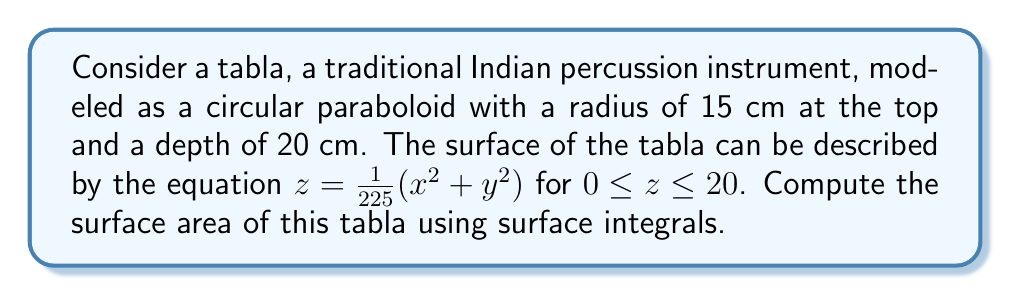Give your solution to this math problem. To compute the surface area using surface integrals, we'll follow these steps:

1) The surface area of a function $z = f(x,y)$ over a region $R$ is given by:

   $$A = \iint_R \sqrt{1 + \left(\frac{\partial z}{\partial x}\right)^2 + \left(\frac{\partial z}{\partial y}\right)^2} dA$$

2) For our paraboloid, $z = \frac{1}{225}(x^2 + y^2)$. Let's calculate the partial derivatives:

   $\frac{\partial z}{\partial x} = \frac{2x}{225}$
   $\frac{\partial z}{\partial y} = \frac{2y}{225}$

3) Substituting these into our surface area formula:

   $$A = \iint_R \sqrt{1 + \left(\frac{2x}{225}\right)^2 + \left(\frac{2y}{225}\right)^2} dA$$

4) The region $R$ is a circle with radius 15. It's easier to use polar coordinates here. The transformation is:

   $x = r\cos\theta$
   $y = r\sin\theta$
   $dA = r dr d\theta$

5) Our integral becomes:

   $$A = \int_0^{2\pi} \int_0^{15} \sqrt{1 + \left(\frac{2r}{225}\right)^2} r dr d\theta$$

6) Simplify the integrand:

   $$A = \int_0^{2\pi} \int_0^{15} \sqrt{1 + \frac{4r^2}{50625}} r dr d\theta$$

7) Evaluate the inner integral:

   $$A = \int_0^{2\pi} \left[\frac{50625}{8}\left(\sqrt{1 + \frac{4r^2}{50625}} - 1\right)\right]_0^{15} d\theta$$

8) Substitute the limits:

   $$A = \int_0^{2\pi} \frac{50625}{8}\left(\sqrt{1 + \frac{900}{50625}} - 1\right) d\theta$$

9) Simplify:

   $$A = \int_0^{2\pi} \frac{50625}{8}\left(\sqrt{\frac{51525}{50625}} - 1\right) d\theta$$

10) Evaluate the outer integral:

    $$A = 2\pi \cdot \frac{50625}{8}\left(\sqrt{\frac{51525}{50625}} - 1\right)$$

11) Simplify to get the final answer:

    $$A = 2\pi \cdot \frac{50625}{8}\left(\sqrt{1.0178} - 1\right) \approx 706.86 \text{ cm}^2$$
Answer: $706.86 \text{ cm}^2$ 